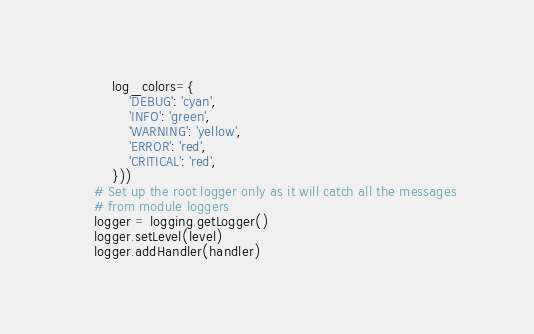<code> <loc_0><loc_0><loc_500><loc_500><_Python_>        log_colors={
            'DEBUG': 'cyan',
            'INFO': 'green',
            'WARNING': 'yellow',
            'ERROR': 'red',
            'CRITICAL': 'red',
        }))
    # Set up the root logger only as it will catch all the messages
    # from module loggers
    logger = logging.getLogger()
    logger.setLevel(level)
    logger.addHandler(handler)
</code> 